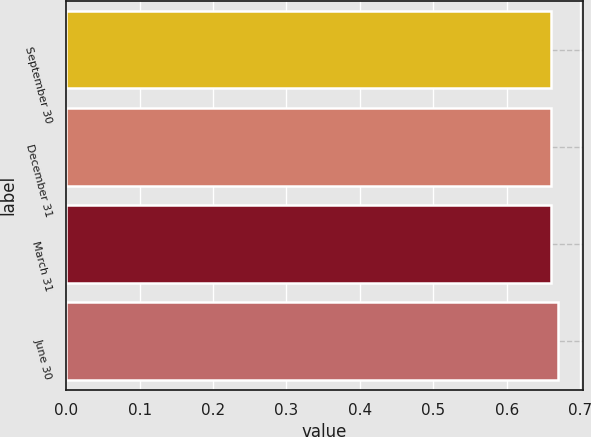Convert chart to OTSL. <chart><loc_0><loc_0><loc_500><loc_500><bar_chart><fcel>September 30<fcel>December 31<fcel>March 31<fcel>June 30<nl><fcel>0.66<fcel>0.66<fcel>0.66<fcel>0.67<nl></chart> 